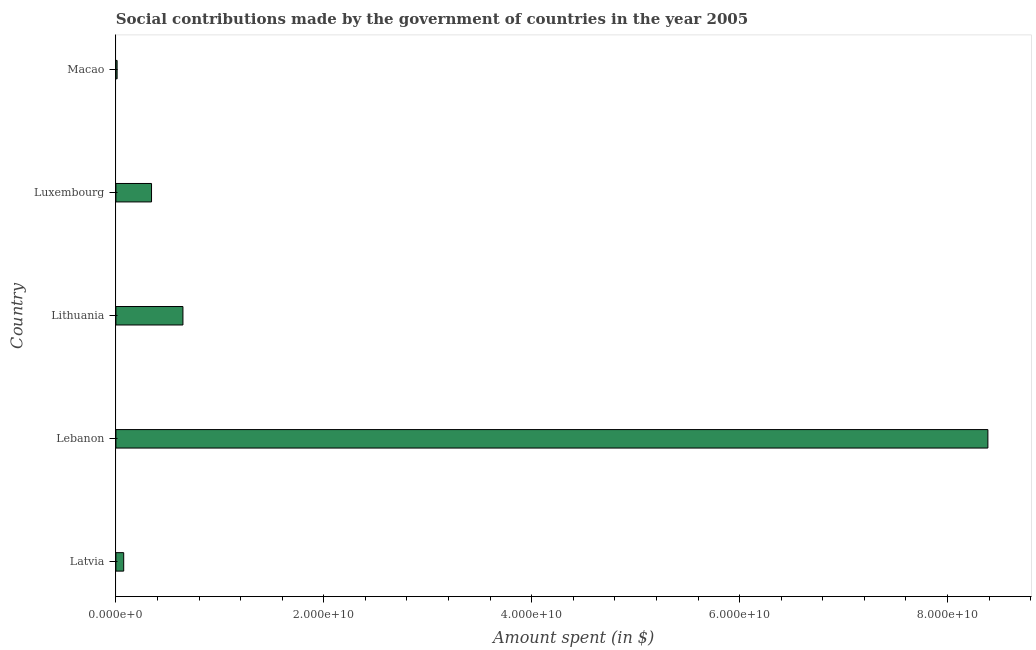Does the graph contain any zero values?
Provide a short and direct response. No. What is the title of the graph?
Provide a short and direct response. Social contributions made by the government of countries in the year 2005. What is the label or title of the X-axis?
Your answer should be compact. Amount spent (in $). What is the label or title of the Y-axis?
Provide a succinct answer. Country. What is the amount spent in making social contributions in Macao?
Give a very brief answer. 1.18e+08. Across all countries, what is the maximum amount spent in making social contributions?
Make the answer very short. 8.39e+1. Across all countries, what is the minimum amount spent in making social contributions?
Your response must be concise. 1.18e+08. In which country was the amount spent in making social contributions maximum?
Offer a terse response. Lebanon. In which country was the amount spent in making social contributions minimum?
Offer a terse response. Macao. What is the sum of the amount spent in making social contributions?
Offer a terse response. 9.46e+1. What is the difference between the amount spent in making social contributions in Lebanon and Macao?
Offer a very short reply. 8.38e+1. What is the average amount spent in making social contributions per country?
Make the answer very short. 1.89e+1. What is the median amount spent in making social contributions?
Give a very brief answer. 3.43e+09. What is the ratio of the amount spent in making social contributions in Lebanon to that in Macao?
Give a very brief answer. 710.83. What is the difference between the highest and the second highest amount spent in making social contributions?
Provide a succinct answer. 7.74e+1. What is the difference between the highest and the lowest amount spent in making social contributions?
Your answer should be very brief. 8.38e+1. How many countries are there in the graph?
Keep it short and to the point. 5. Are the values on the major ticks of X-axis written in scientific E-notation?
Make the answer very short. Yes. What is the Amount spent (in $) in Latvia?
Ensure brevity in your answer.  7.51e+08. What is the Amount spent (in $) of Lebanon?
Give a very brief answer. 8.39e+1. What is the Amount spent (in $) of Lithuania?
Your answer should be compact. 6.45e+09. What is the Amount spent (in $) of Luxembourg?
Your response must be concise. 3.43e+09. What is the Amount spent (in $) in Macao?
Make the answer very short. 1.18e+08. What is the difference between the Amount spent (in $) in Latvia and Lebanon?
Provide a succinct answer. -8.31e+1. What is the difference between the Amount spent (in $) in Latvia and Lithuania?
Give a very brief answer. -5.70e+09. What is the difference between the Amount spent (in $) in Latvia and Luxembourg?
Provide a succinct answer. -2.68e+09. What is the difference between the Amount spent (in $) in Latvia and Macao?
Offer a terse response. 6.33e+08. What is the difference between the Amount spent (in $) in Lebanon and Lithuania?
Your answer should be compact. 7.74e+1. What is the difference between the Amount spent (in $) in Lebanon and Luxembourg?
Offer a very short reply. 8.05e+1. What is the difference between the Amount spent (in $) in Lebanon and Macao?
Ensure brevity in your answer.  8.38e+1. What is the difference between the Amount spent (in $) in Lithuania and Luxembourg?
Provide a succinct answer. 3.02e+09. What is the difference between the Amount spent (in $) in Lithuania and Macao?
Your answer should be compact. 6.33e+09. What is the difference between the Amount spent (in $) in Luxembourg and Macao?
Make the answer very short. 3.31e+09. What is the ratio of the Amount spent (in $) in Latvia to that in Lebanon?
Offer a very short reply. 0.01. What is the ratio of the Amount spent (in $) in Latvia to that in Lithuania?
Keep it short and to the point. 0.12. What is the ratio of the Amount spent (in $) in Latvia to that in Luxembourg?
Offer a terse response. 0.22. What is the ratio of the Amount spent (in $) in Latvia to that in Macao?
Provide a succinct answer. 6.37. What is the ratio of the Amount spent (in $) in Lebanon to that in Lithuania?
Your response must be concise. 13.01. What is the ratio of the Amount spent (in $) in Lebanon to that in Luxembourg?
Offer a terse response. 24.47. What is the ratio of the Amount spent (in $) in Lebanon to that in Macao?
Offer a terse response. 710.83. What is the ratio of the Amount spent (in $) in Lithuania to that in Luxembourg?
Give a very brief answer. 1.88. What is the ratio of the Amount spent (in $) in Lithuania to that in Macao?
Provide a short and direct response. 54.66. What is the ratio of the Amount spent (in $) in Luxembourg to that in Macao?
Provide a short and direct response. 29.05. 